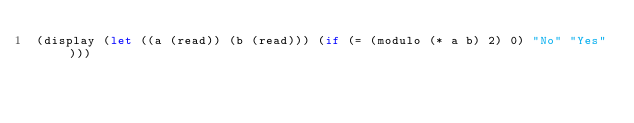Convert code to text. <code><loc_0><loc_0><loc_500><loc_500><_Scheme_>(display (let ((a (read)) (b (read))) (if (= (modulo (* a b) 2) 0) "No" "Yes")))</code> 